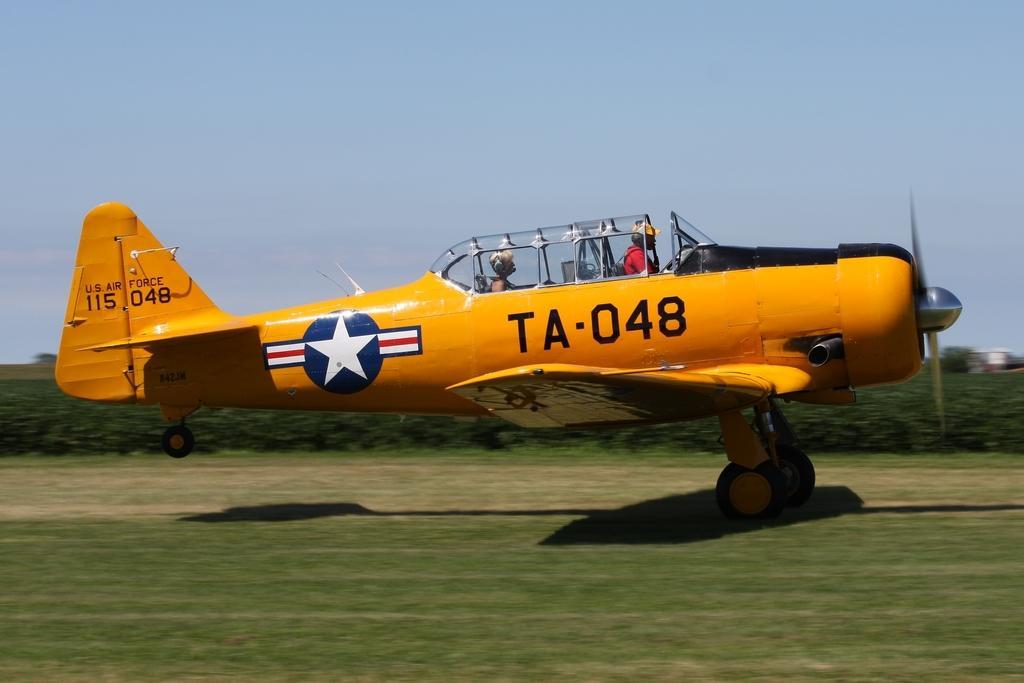In one or two sentences, can you explain what this image depicts? In the picture I can see an aircraft and I can see two persons in the aircraft. I can see the green grass at the bottom of the picture. In the background, I can see the trees. There are clouds in the sky. 